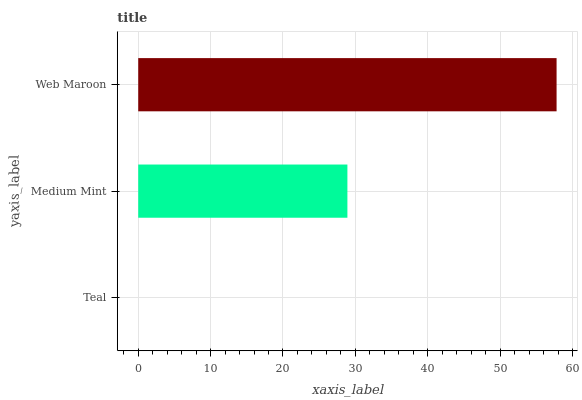Is Teal the minimum?
Answer yes or no. Yes. Is Web Maroon the maximum?
Answer yes or no. Yes. Is Medium Mint the minimum?
Answer yes or no. No. Is Medium Mint the maximum?
Answer yes or no. No. Is Medium Mint greater than Teal?
Answer yes or no. Yes. Is Teal less than Medium Mint?
Answer yes or no. Yes. Is Teal greater than Medium Mint?
Answer yes or no. No. Is Medium Mint less than Teal?
Answer yes or no. No. Is Medium Mint the high median?
Answer yes or no. Yes. Is Medium Mint the low median?
Answer yes or no. Yes. Is Web Maroon the high median?
Answer yes or no. No. Is Web Maroon the low median?
Answer yes or no. No. 